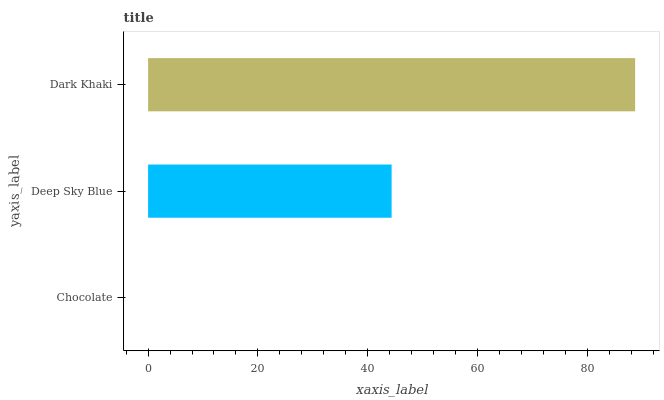Is Chocolate the minimum?
Answer yes or no. Yes. Is Dark Khaki the maximum?
Answer yes or no. Yes. Is Deep Sky Blue the minimum?
Answer yes or no. No. Is Deep Sky Blue the maximum?
Answer yes or no. No. Is Deep Sky Blue greater than Chocolate?
Answer yes or no. Yes. Is Chocolate less than Deep Sky Blue?
Answer yes or no. Yes. Is Chocolate greater than Deep Sky Blue?
Answer yes or no. No. Is Deep Sky Blue less than Chocolate?
Answer yes or no. No. Is Deep Sky Blue the high median?
Answer yes or no. Yes. Is Deep Sky Blue the low median?
Answer yes or no. Yes. Is Chocolate the high median?
Answer yes or no. No. Is Dark Khaki the low median?
Answer yes or no. No. 